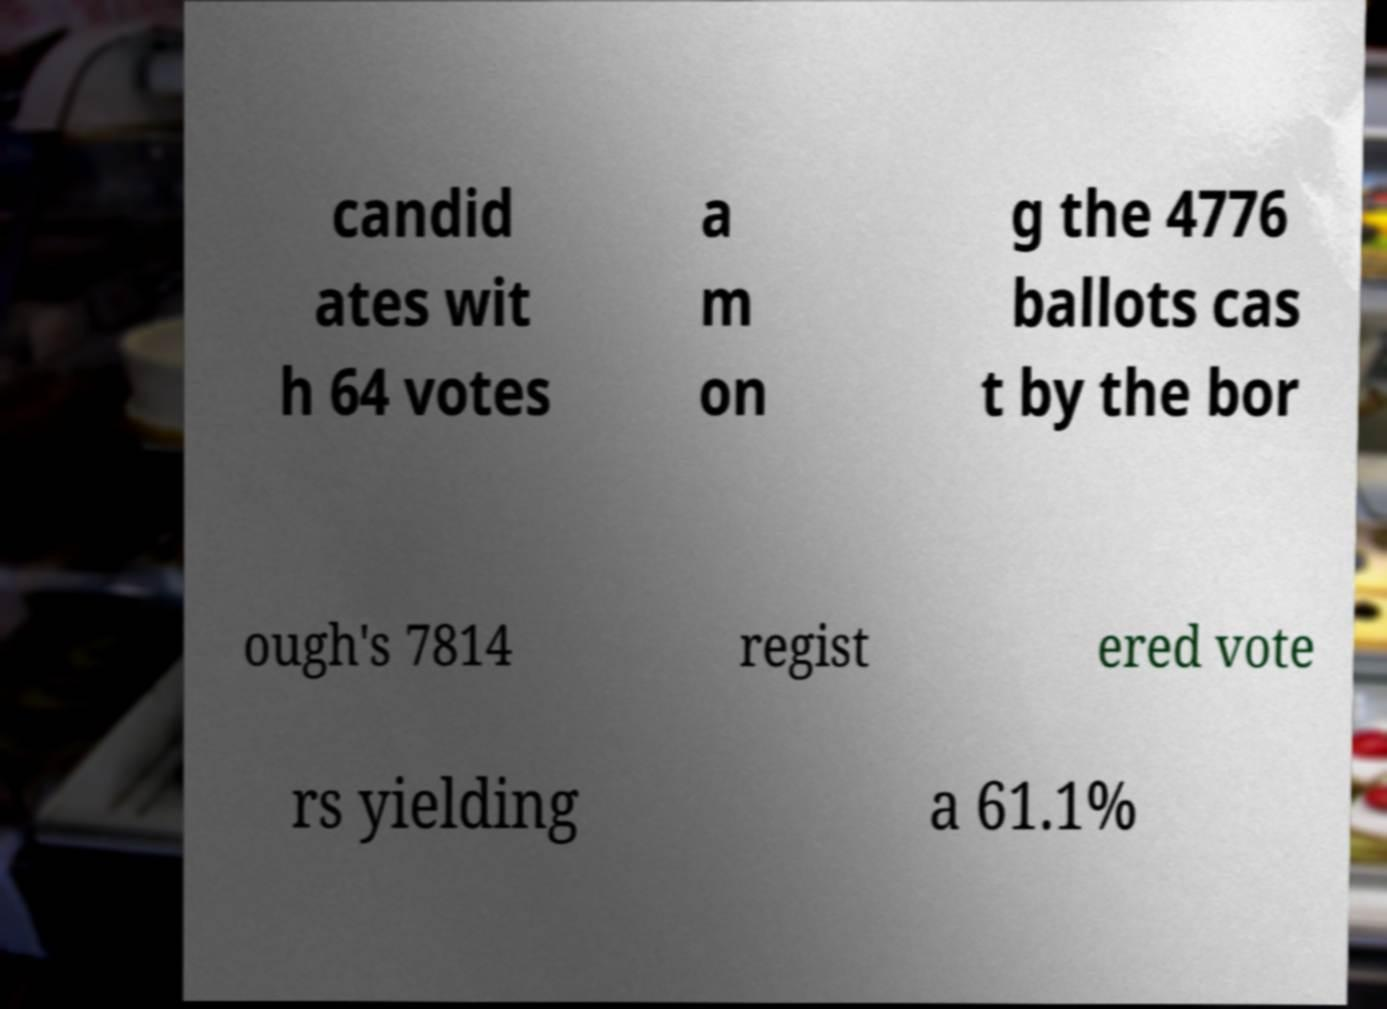I need the written content from this picture converted into text. Can you do that? candid ates wit h 64 votes a m on g the 4776 ballots cas t by the bor ough's 7814 regist ered vote rs yielding a 61.1% 